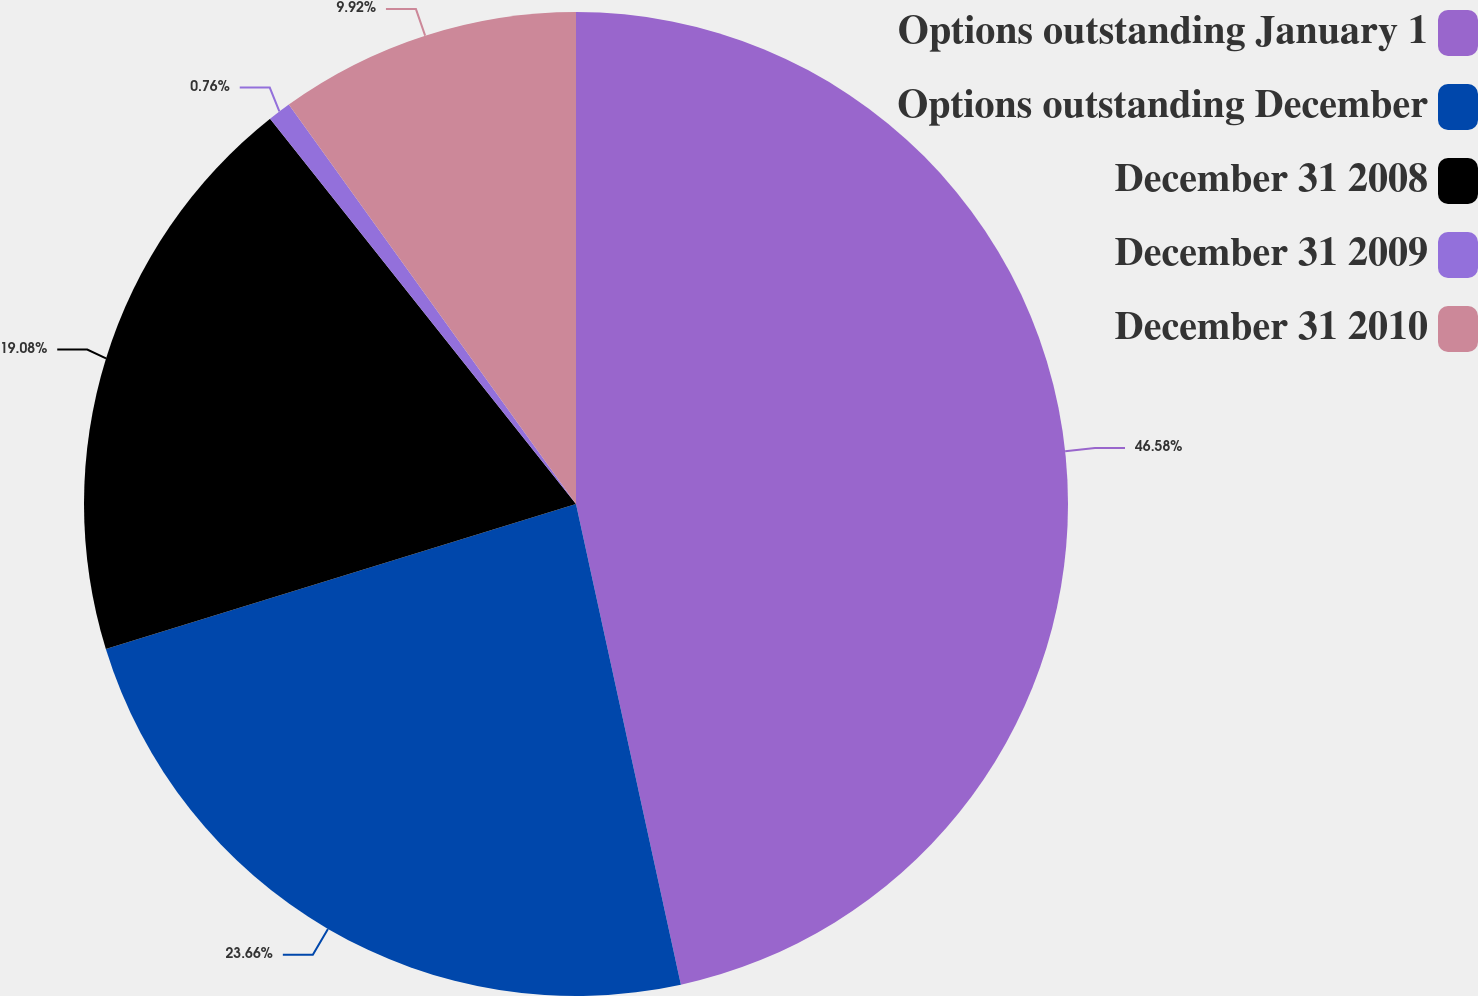Convert chart to OTSL. <chart><loc_0><loc_0><loc_500><loc_500><pie_chart><fcel>Options outstanding January 1<fcel>Options outstanding December<fcel>December 31 2008<fcel>December 31 2009<fcel>December 31 2010<nl><fcel>46.58%<fcel>23.66%<fcel>19.08%<fcel>0.76%<fcel>9.92%<nl></chart> 